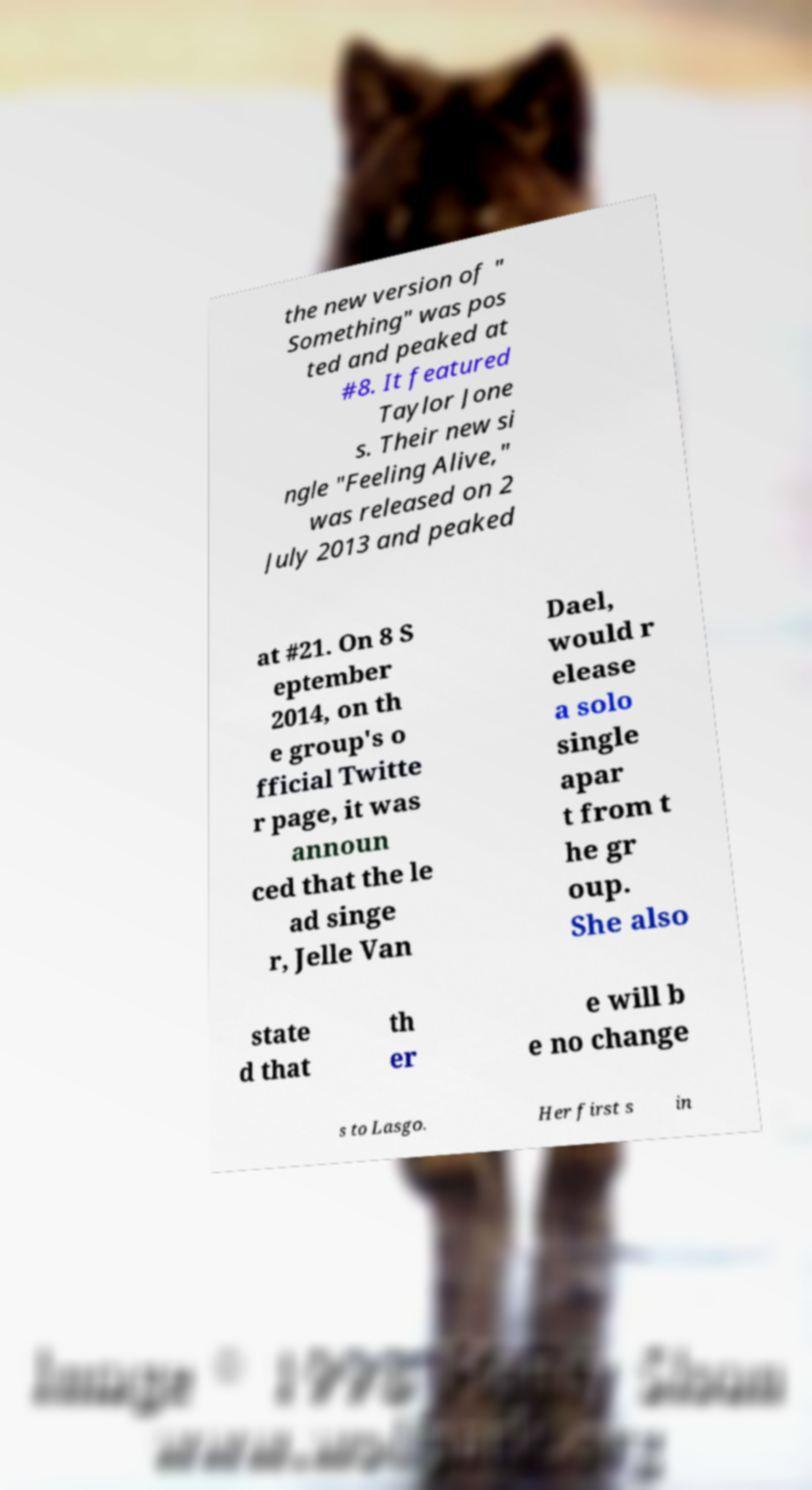For documentation purposes, I need the text within this image transcribed. Could you provide that? the new version of " Something" was pos ted and peaked at #8. It featured Taylor Jone s. Their new si ngle "Feeling Alive," was released on 2 July 2013 and peaked at #21. On 8 S eptember 2014, on th e group's o fficial Twitte r page, it was announ ced that the le ad singe r, Jelle Van Dael, would r elease a solo single apar t from t he gr oup. She also state d that th er e will b e no change s to Lasgo. Her first s in 